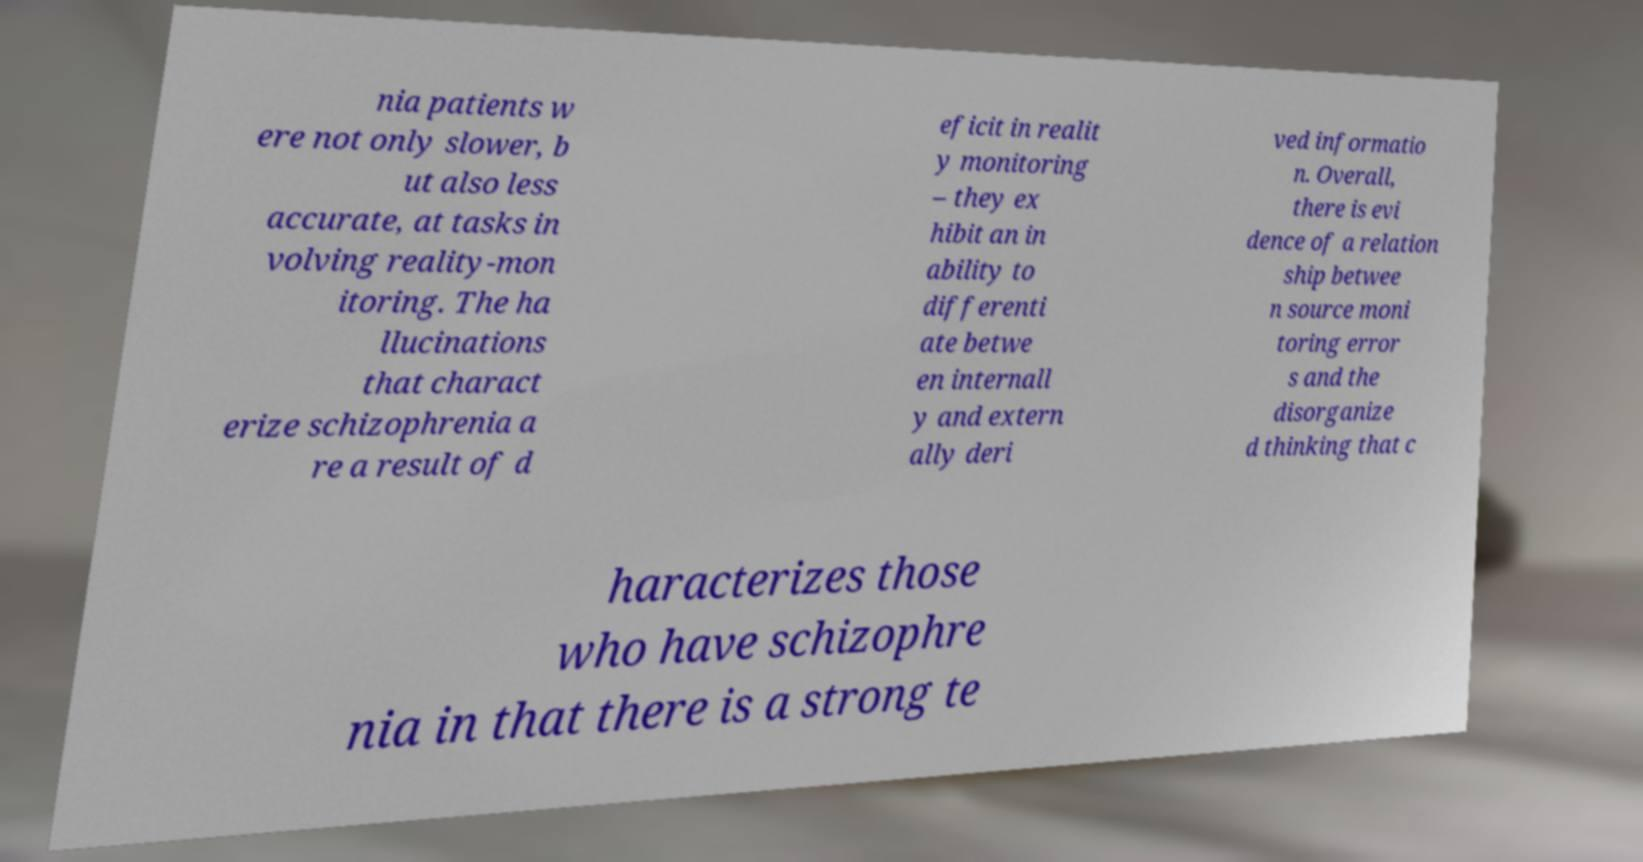There's text embedded in this image that I need extracted. Can you transcribe it verbatim? nia patients w ere not only slower, b ut also less accurate, at tasks in volving reality-mon itoring. The ha llucinations that charact erize schizophrenia a re a result of d eficit in realit y monitoring – they ex hibit an in ability to differenti ate betwe en internall y and extern ally deri ved informatio n. Overall, there is evi dence of a relation ship betwee n source moni toring error s and the disorganize d thinking that c haracterizes those who have schizophre nia in that there is a strong te 